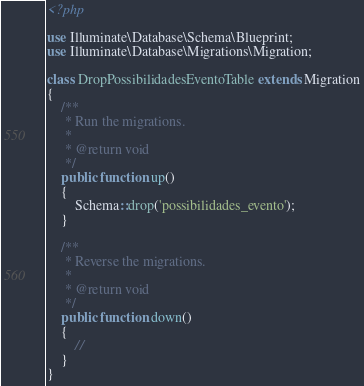<code> <loc_0><loc_0><loc_500><loc_500><_PHP_><?php

use Illuminate\Database\Schema\Blueprint;
use Illuminate\Database\Migrations\Migration;

class DropPossibilidadesEventoTable extends Migration
{
    /**
     * Run the migrations.
     *
     * @return void
     */
    public function up()
    {
        Schema::drop('possibilidades_evento');
    }

    /**
     * Reverse the migrations.
     *
     * @return void
     */
    public function down()
    {
        //
    }
}
</code> 